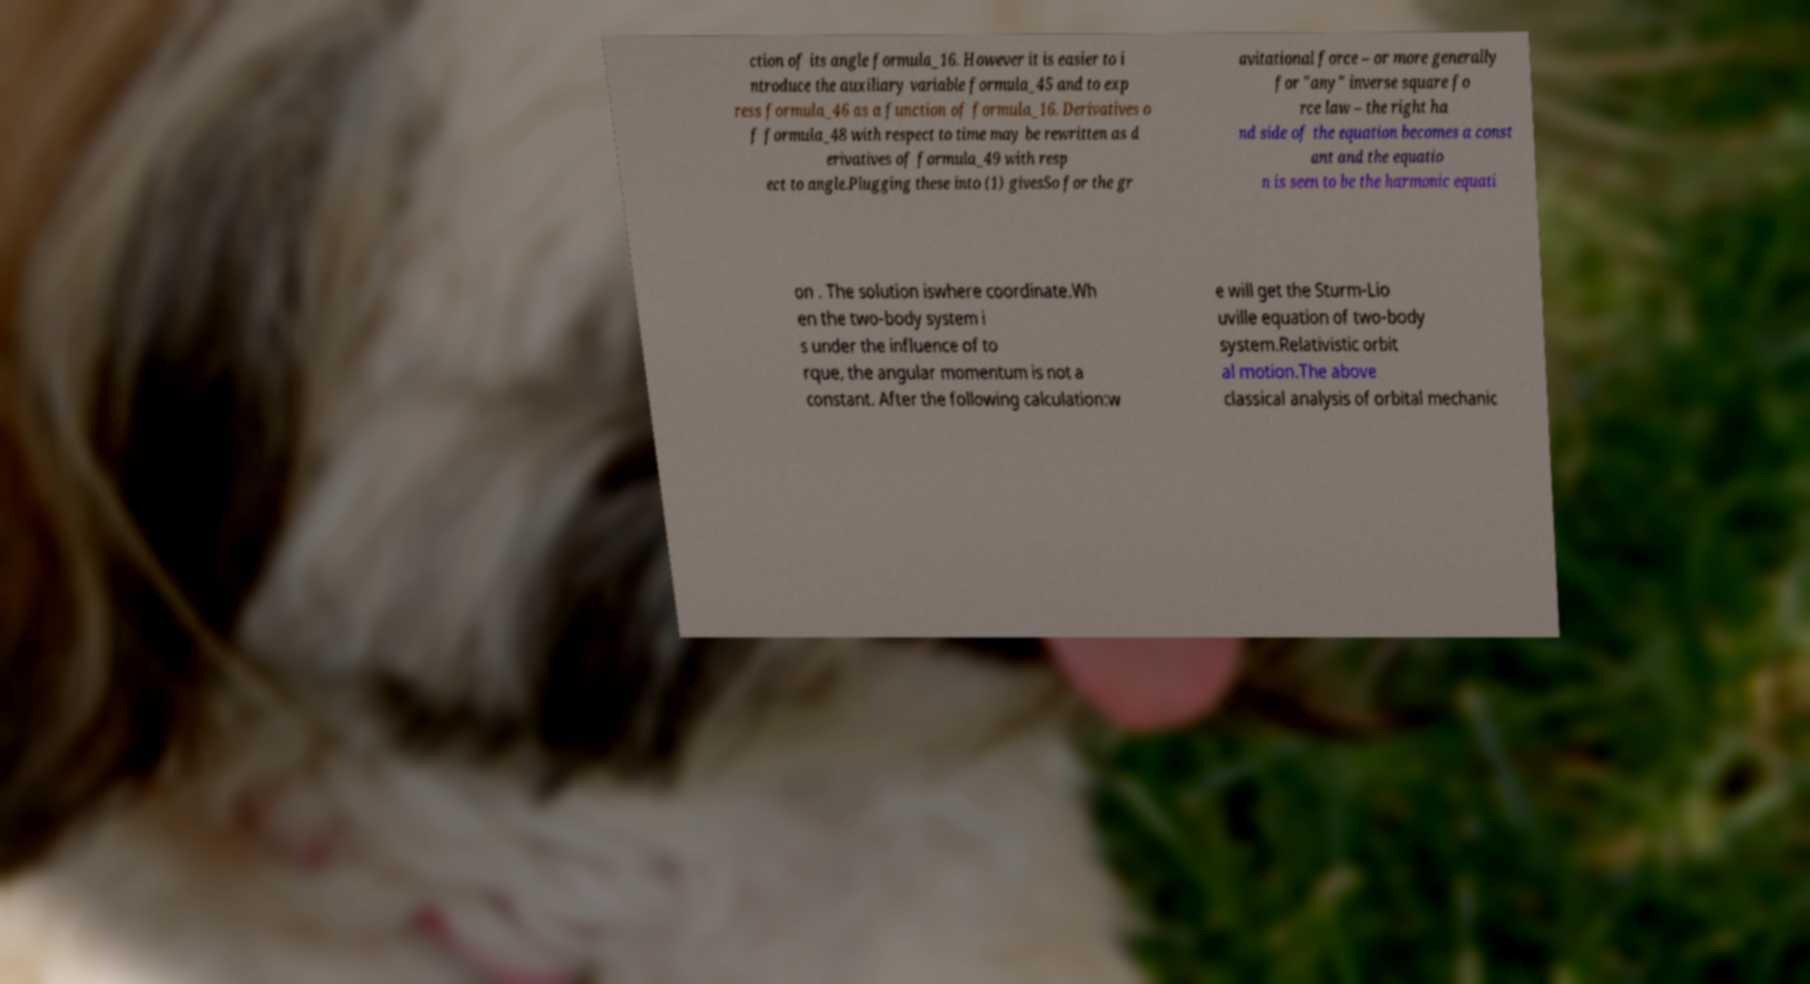There's text embedded in this image that I need extracted. Can you transcribe it verbatim? ction of its angle formula_16. However it is easier to i ntroduce the auxiliary variable formula_45 and to exp ress formula_46 as a function of formula_16. Derivatives o f formula_48 with respect to time may be rewritten as d erivatives of formula_49 with resp ect to angle.Plugging these into (1) givesSo for the gr avitational force – or more generally for "any" inverse square fo rce law – the right ha nd side of the equation becomes a const ant and the equatio n is seen to be the harmonic equati on . The solution iswhere coordinate.Wh en the two-body system i s under the influence of to rque, the angular momentum is not a constant. After the following calculation:w e will get the Sturm-Lio uville equation of two-body system.Relativistic orbit al motion.The above classical analysis of orbital mechanic 